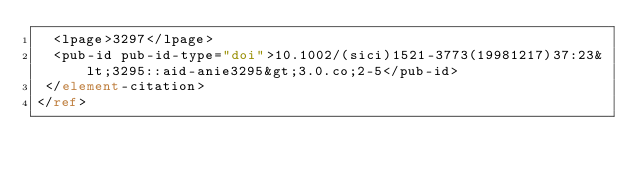Convert code to text. <code><loc_0><loc_0><loc_500><loc_500><_XML_>  <lpage>3297</lpage>
  <pub-id pub-id-type="doi">10.1002/(sici)1521-3773(19981217)37:23&lt;3295::aid-anie3295&gt;3.0.co;2-5</pub-id>
 </element-citation>
</ref>
</code> 